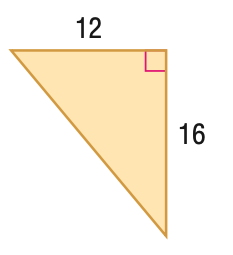Answer the mathemtical geometry problem and directly provide the correct option letter.
Question: Find the perimeter of the figure.
Choices: A: 28 B: 48 C: 96 D: 192 B 